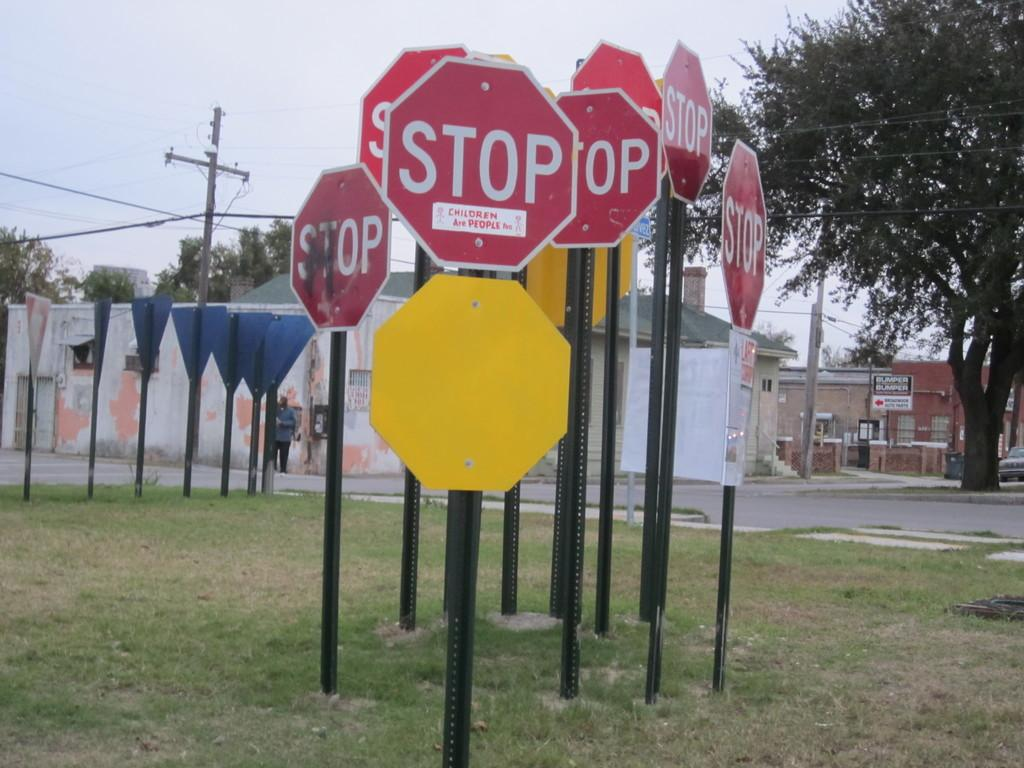Provide a one-sentence caption for the provided image. A cluster of signs in a patch of grass and they all say Stop. 